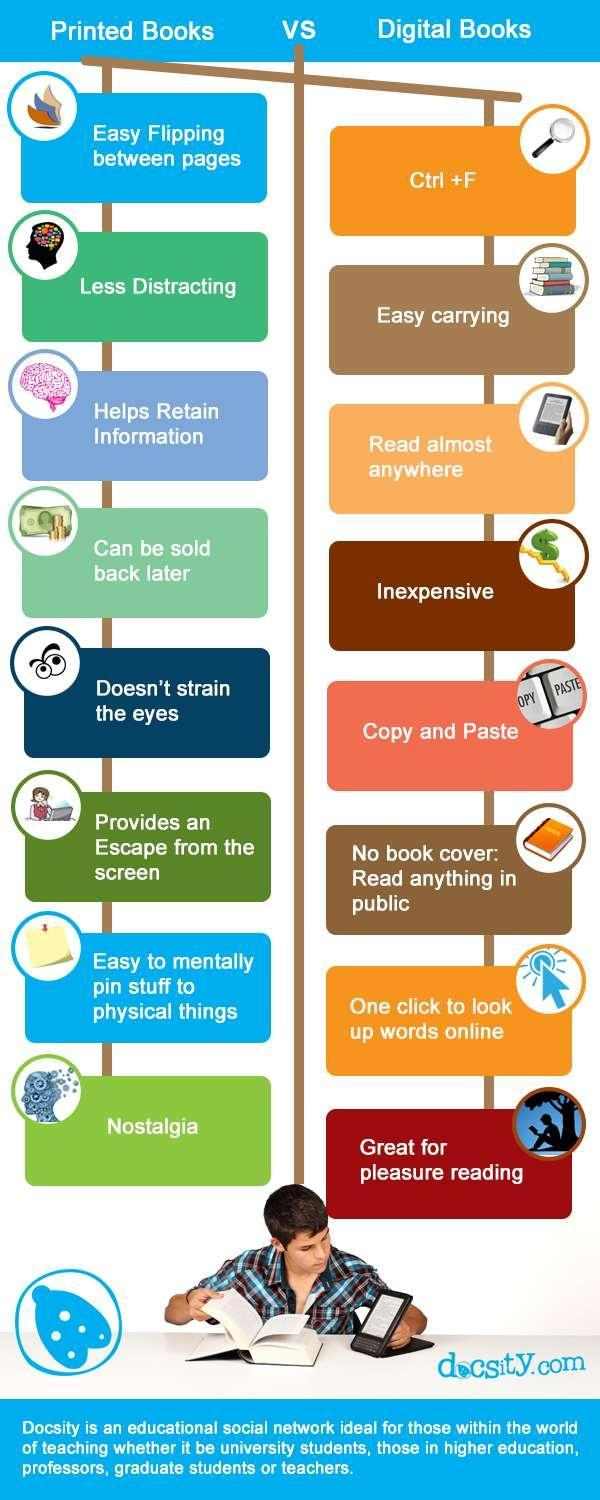Which type of books are less distracting?
Answer the question with a short phrase. Printed books What is the fifth benefit mentioned about printed books? Doesn't strain the eyes Which type of books help to retain information? Printed books Which type of books are comparatively inexpensive? digital books In which type of books we can search for words in one click? digital books Which type of books are easy to carry? digital books What is listed third among the advantages of digital books? Read almost anywhere Which type of books helps to copy and paste text? digital books Which type of books makes it easy to mentally pin stuff to physical things? Printed books Which type of books give a feeling of nostalgia? Printed books 